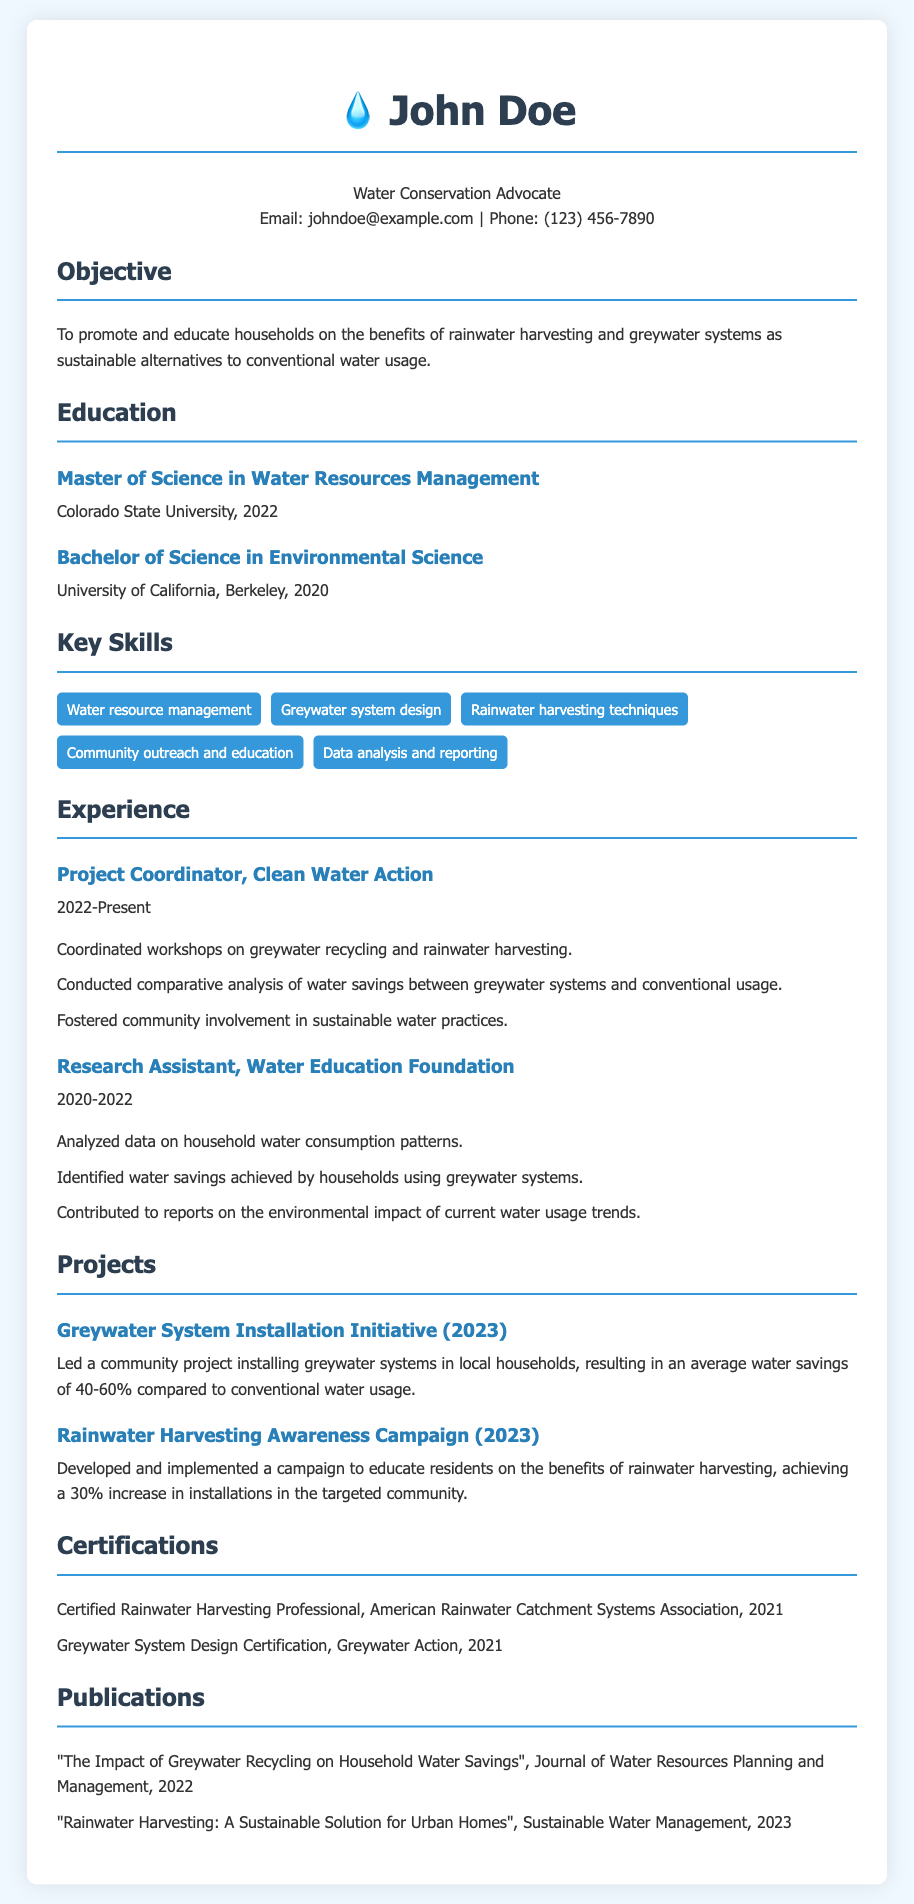what is the name of the advocate? The advocate's name is prominently displayed in the header of the CV.
Answer: John Doe what is the email address provided? The email address is located in the contact information section of the CV.
Answer: johndoe@example.com what degree did John Doe earn in 2022? This information is found in the education section, listing John Doe's advanced degree.
Answer: Master of Science in Water Resources Management what was the percentage of water savings achieved in the Greywater System Installation Initiative? This percentage is mentioned in the description of the project in the projects section of the CV.
Answer: 40-60% which organization did John Doe work for as a Project Coordinator? The CV specifically names the organization where John Doe holds the position mentioned.
Answer: Clean Water Action how many years did John Doe work as a Research Assistant? The duration of employment is stated in the experience section of the CV.
Answer: 2 years what type of certification did John Doe receive in 2021? This information is identified under the certifications section of the CV, specifying the type of certification.
Answer: Certified Rainwater Harvesting Professional who published "The Impact of Greywater Recycling on Household Water Savings"? The publication title and author can be located in the publications section of the CV.
Answer: John Doe what was the aim of the Rainwater Harvesting Awareness Campaign? The purpose of the campaign is outlined in the project description within the projects section.
Answer: Educate residents on the benefits of rainwater harvesting 